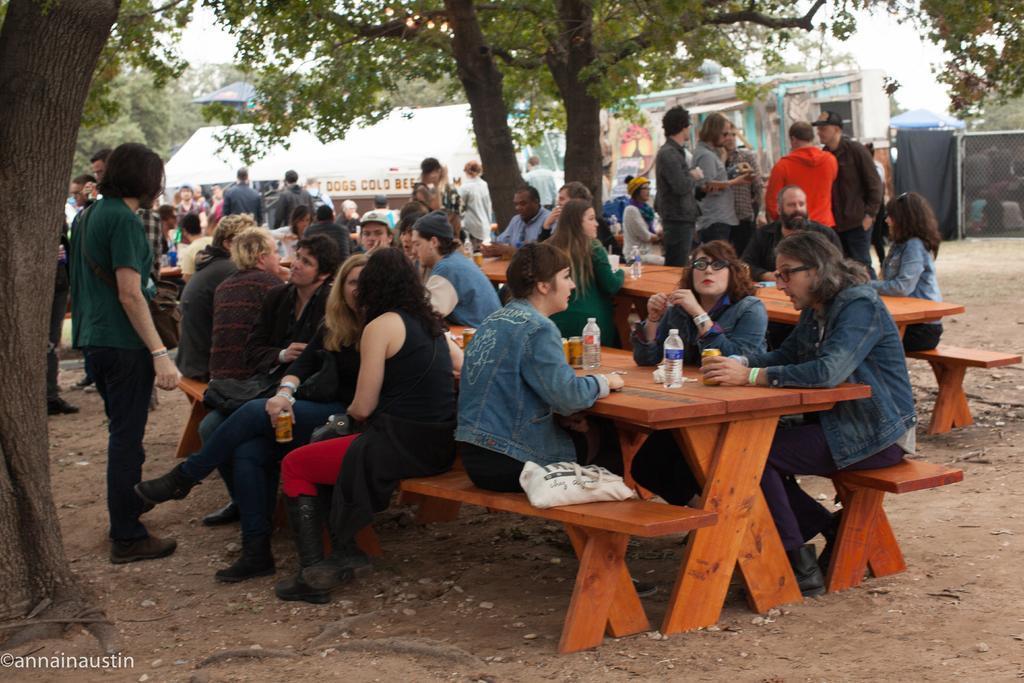Describe this image in one or two sentences. Few people are sitting together on the benches and drinking drinks. 